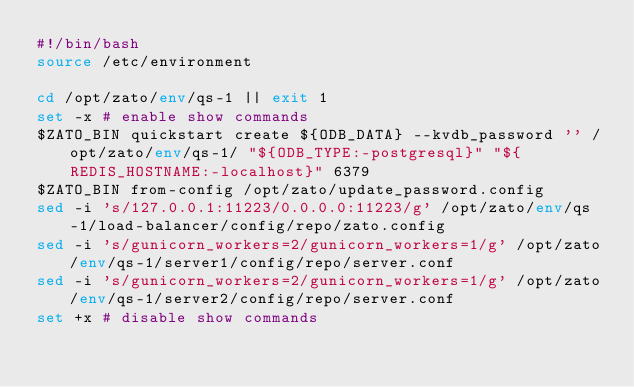<code> <loc_0><loc_0><loc_500><loc_500><_Bash_>#!/bin/bash
source /etc/environment

cd /opt/zato/env/qs-1 || exit 1
set -x # enable show commands
$ZATO_BIN quickstart create ${ODB_DATA} --kvdb_password '' /opt/zato/env/qs-1/ "${ODB_TYPE:-postgresql}" "${REDIS_HOSTNAME:-localhost}" 6379
$ZATO_BIN from-config /opt/zato/update_password.config
sed -i 's/127.0.0.1:11223/0.0.0.0:11223/g' /opt/zato/env/qs-1/load-balancer/config/repo/zato.config
sed -i 's/gunicorn_workers=2/gunicorn_workers=1/g' /opt/zato/env/qs-1/server1/config/repo/server.conf
sed -i 's/gunicorn_workers=2/gunicorn_workers=1/g' /opt/zato/env/qs-1/server2/config/repo/server.conf
set +x # disable show commands
</code> 